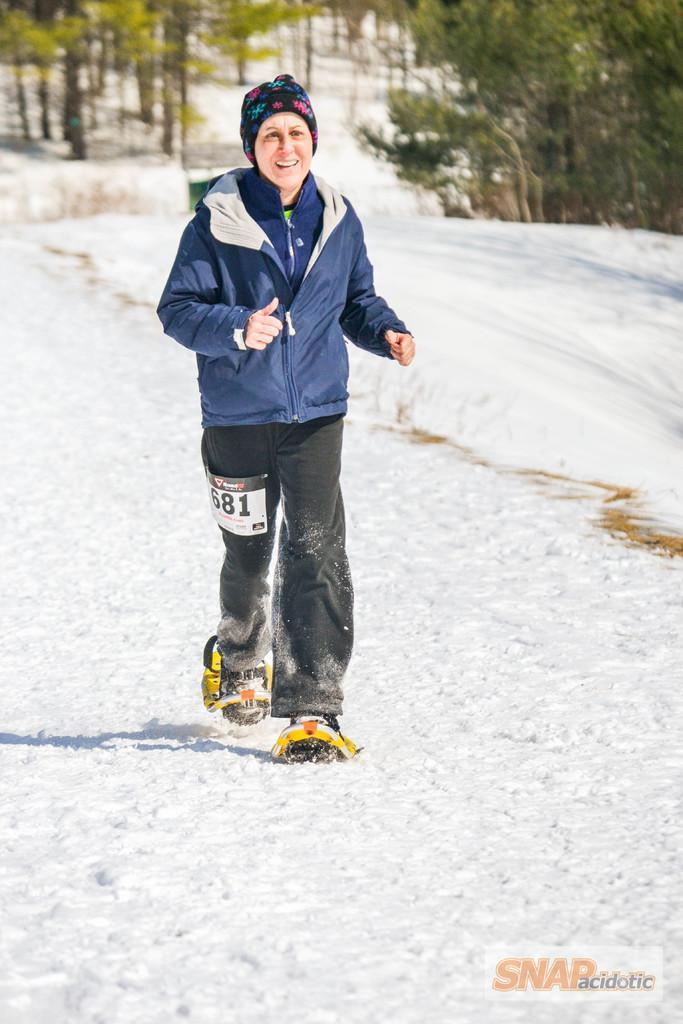Can you describe this image briefly? In this picture we can see a person in the blue jacket is running on the snow with the snowshoes. Behind the person there are trees and on the image there is a watermark. 